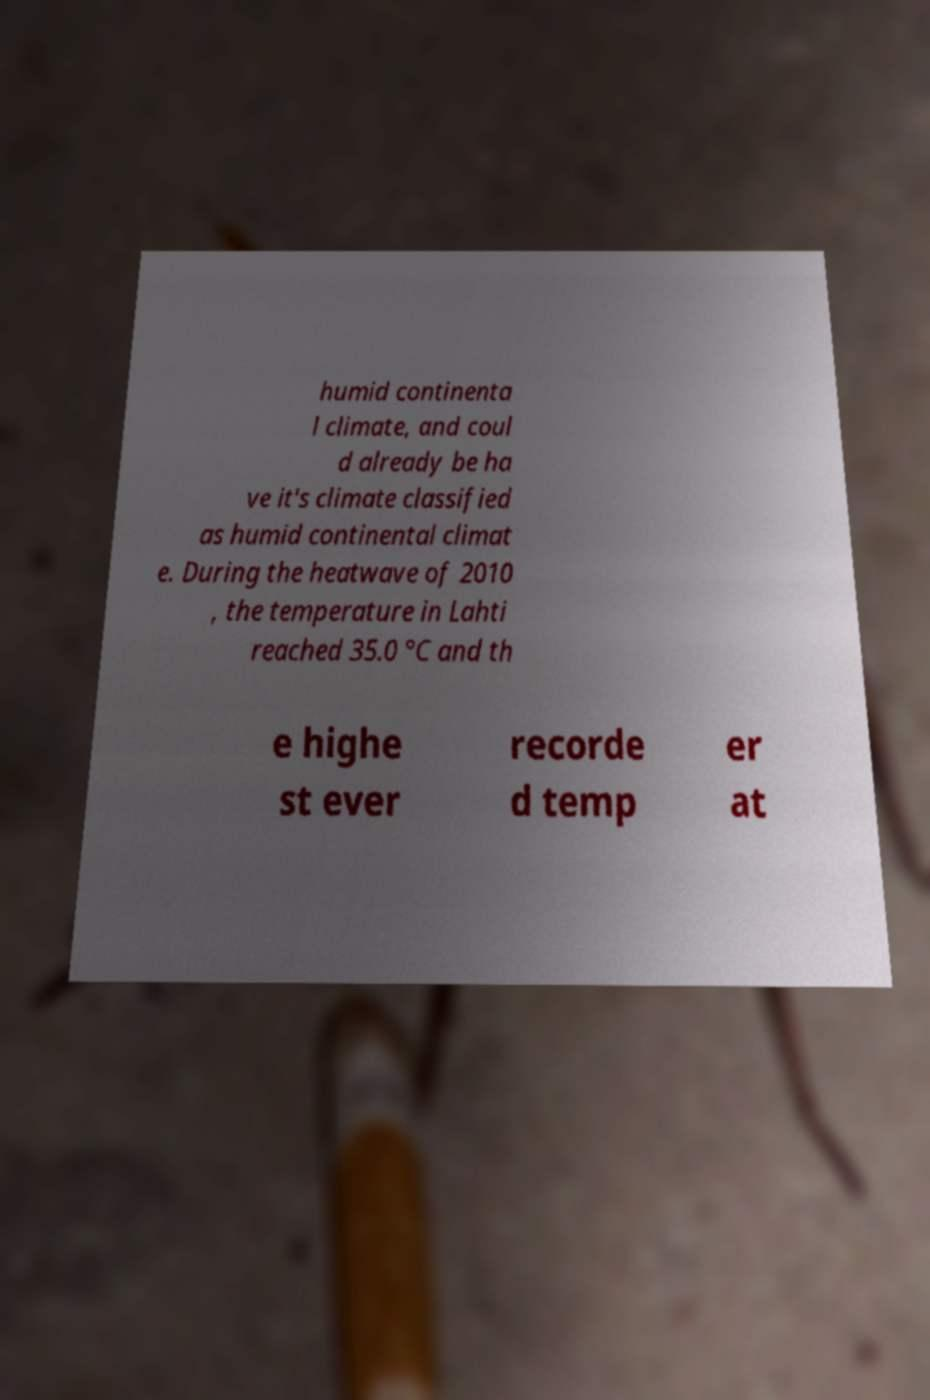For documentation purposes, I need the text within this image transcribed. Could you provide that? humid continenta l climate, and coul d already be ha ve it's climate classified as humid continental climat e. During the heatwave of 2010 , the temperature in Lahti reached 35.0 °C and th e highe st ever recorde d temp er at 